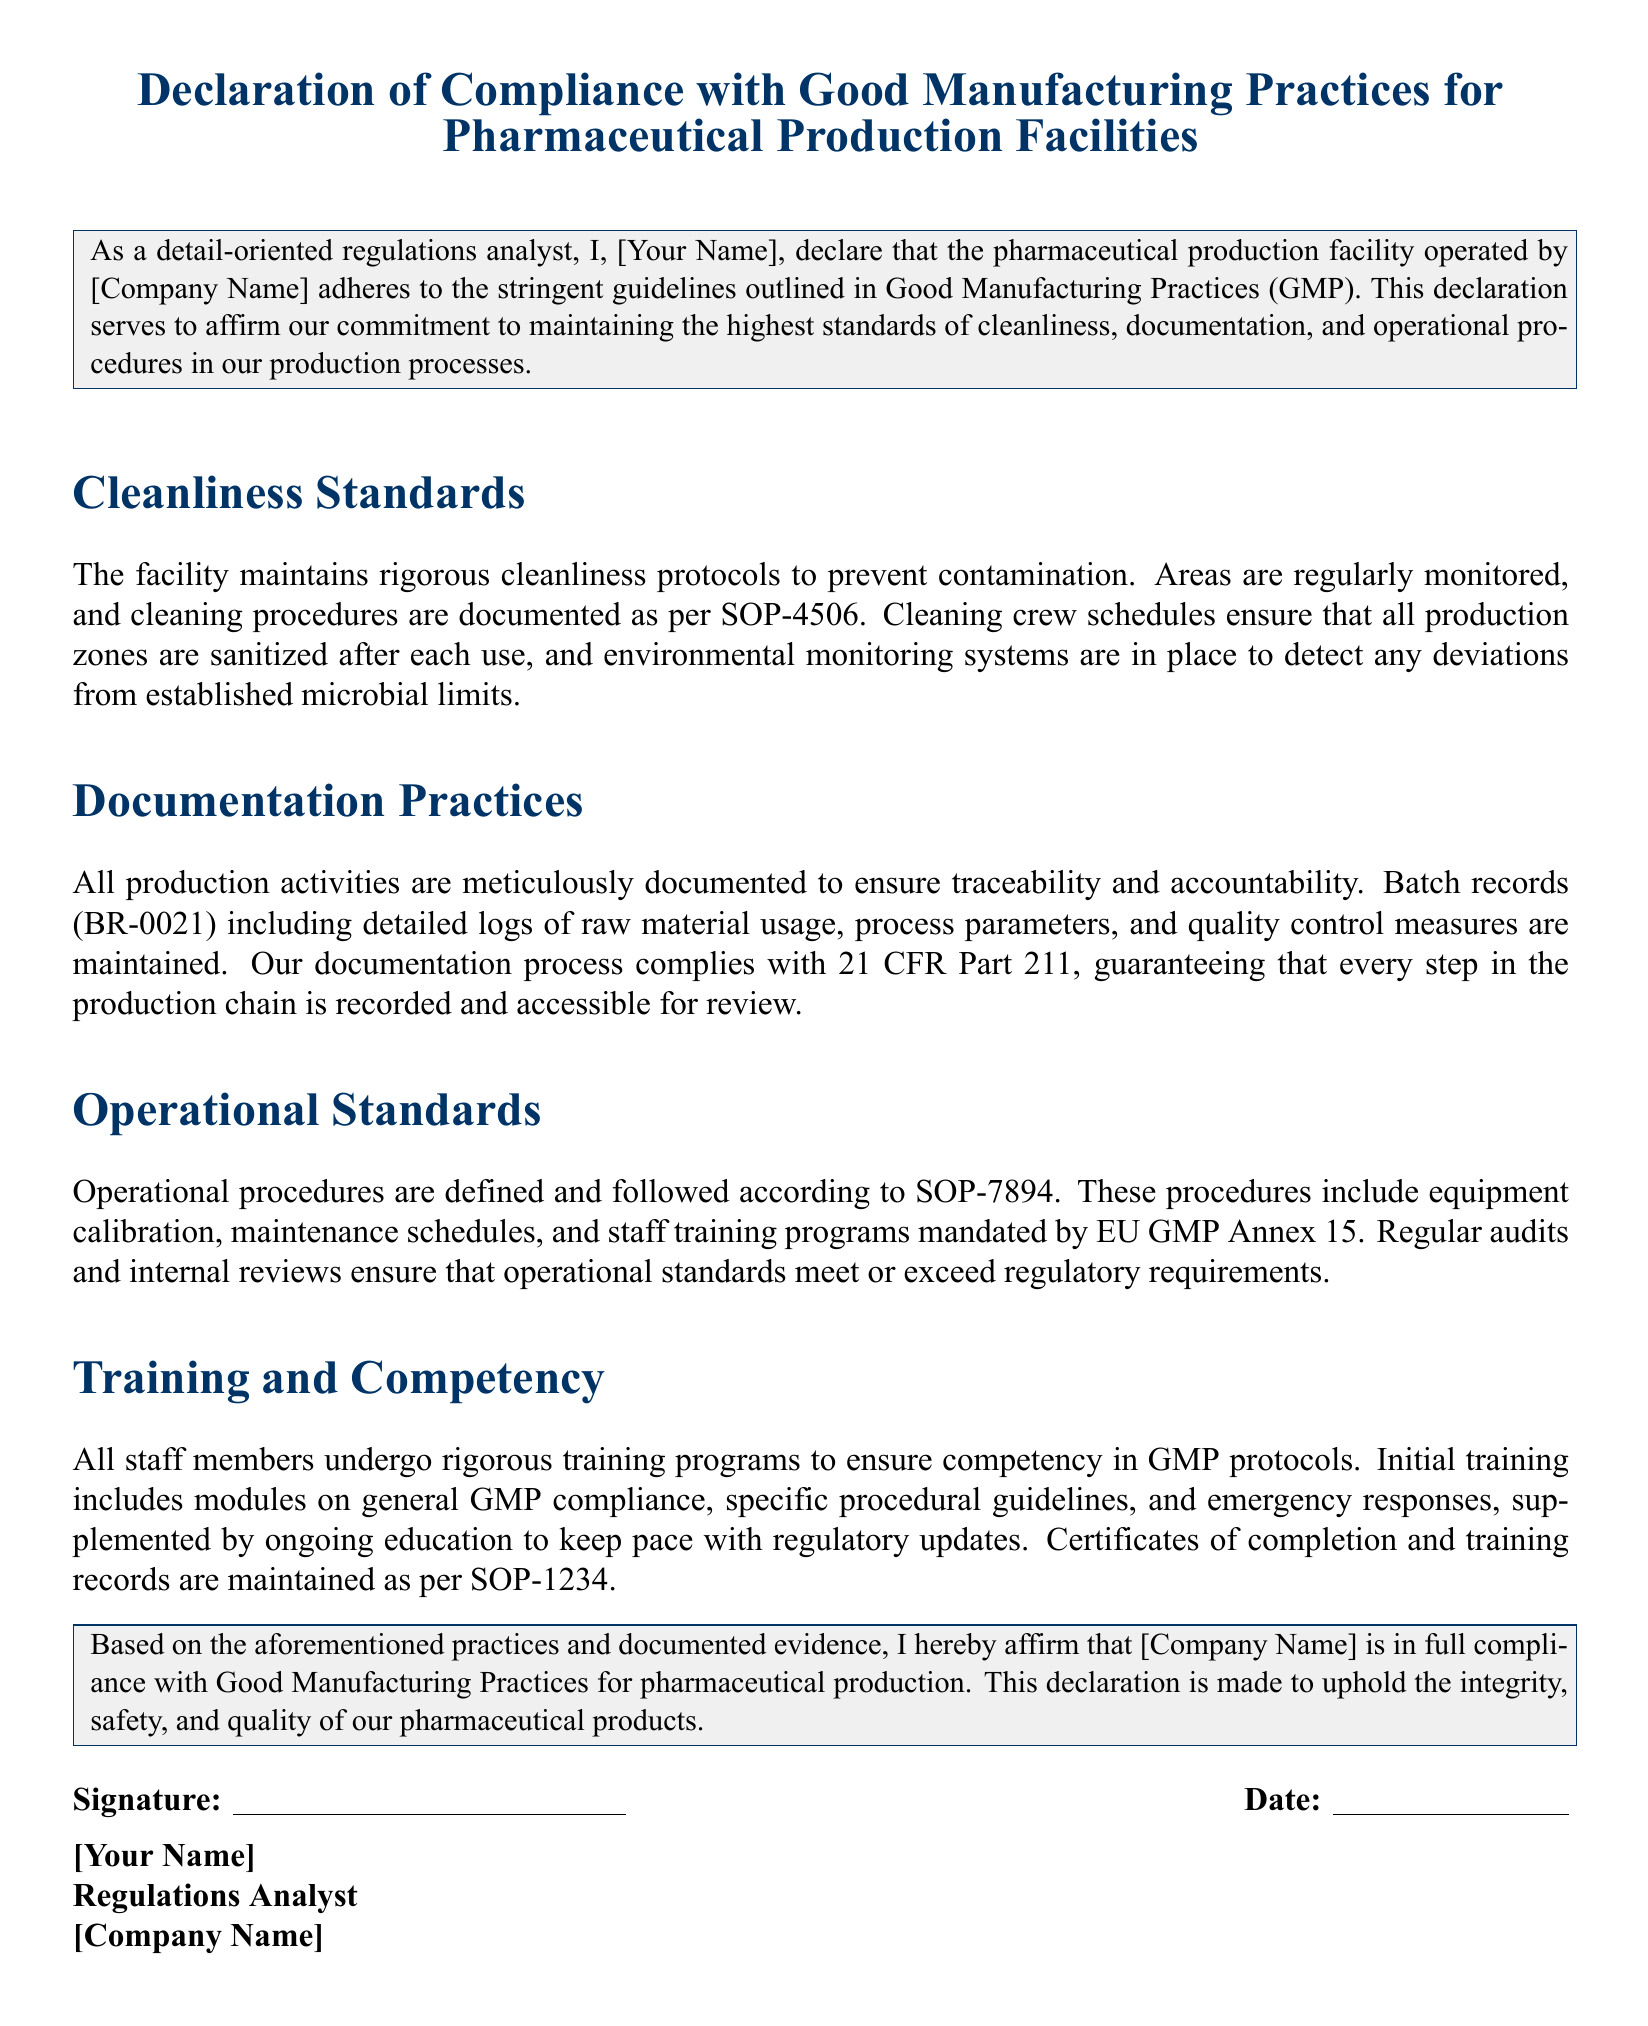What is the name of the document? The title of the document indicates its purpose and is referred to as a "Declaration of Compliance with Good Manufacturing Practices for Pharmaceutical Production Facilities."
Answer: Declaration of Compliance with Good Manufacturing Practices for Pharmaceutical Production Facilities Who is the author of the declaration? The declaration states that it is made by "I, [Your Name]," indicating a placeholder for the author's name.
Answer: [Your Name] What is the SOP number related to cleaning procedures? The document references cleaning procedures that are documented as per SOP-4506.
Answer: SOP-4506 What is the purpose of the batch records? The batch records are specified to ensure traceability and accountability in the production process.
Answer: Traceability and accountability Which regulation is the documentation process compliant with? The document mentions compliance with "21 CFR Part 211" related to its documentation practices.
Answer: 21 CFR Part 211 What training record standard is mentioned? The declaration states that "Certificates of completion and training records are maintained as per SOP-1234."
Answer: SOP-1234 How are cleanliness protocols monitored? The document states that areas are regularly monitored for cleanliness as part of their GMP compliance.
Answer: Regularly monitored What is the date on the signature line? The signature line includes a placeholder for the date of the declaration.
Answer: [Date] What is the main affirmation made at the end of the document? The ending paragraph affirms that the company is in full compliance with GMP for pharmaceutical production.
Answer: Full compliance with GMP What is stated as part of the operational standards? It mentions that operational procedures are defined according to "SOP-7894."
Answer: SOP-7894 